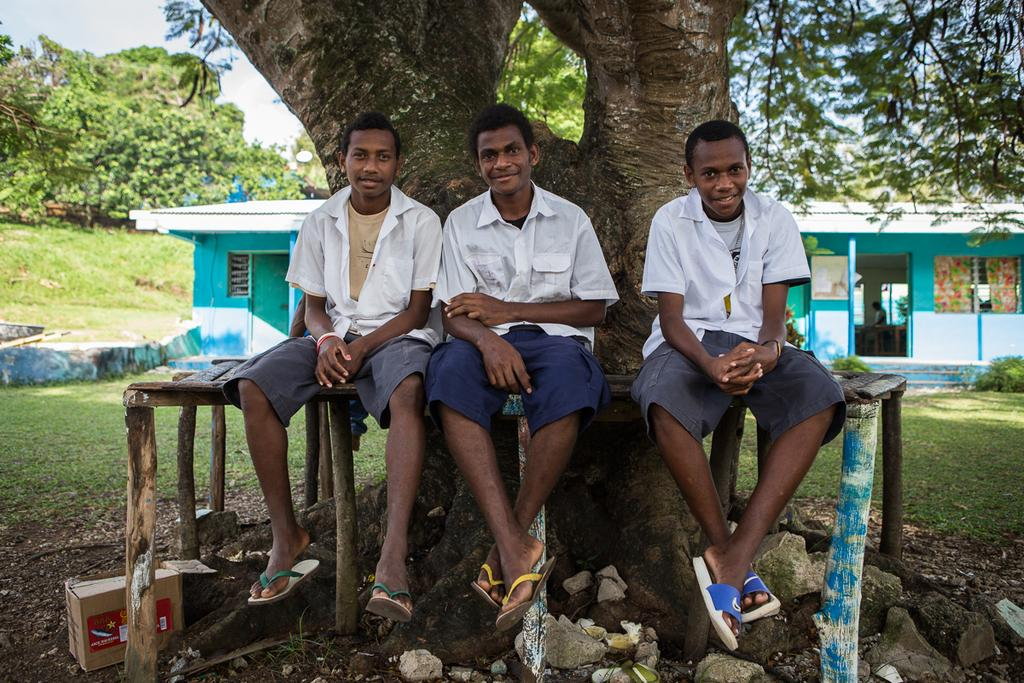How many boys are in the image? There are three boys in the image. What are the boys doing in the image? The boys are sitting on a bench. What can be seen in the background of the image? There are trees, at least one building, and the sky visible in the background of the image. What type of toy is the boys playing with in the image? There is no toy visible in the image; the boys are sitting on a bench. Which direction are the boys facing in the image? The image does not provide information about the direction the boys are facing. 